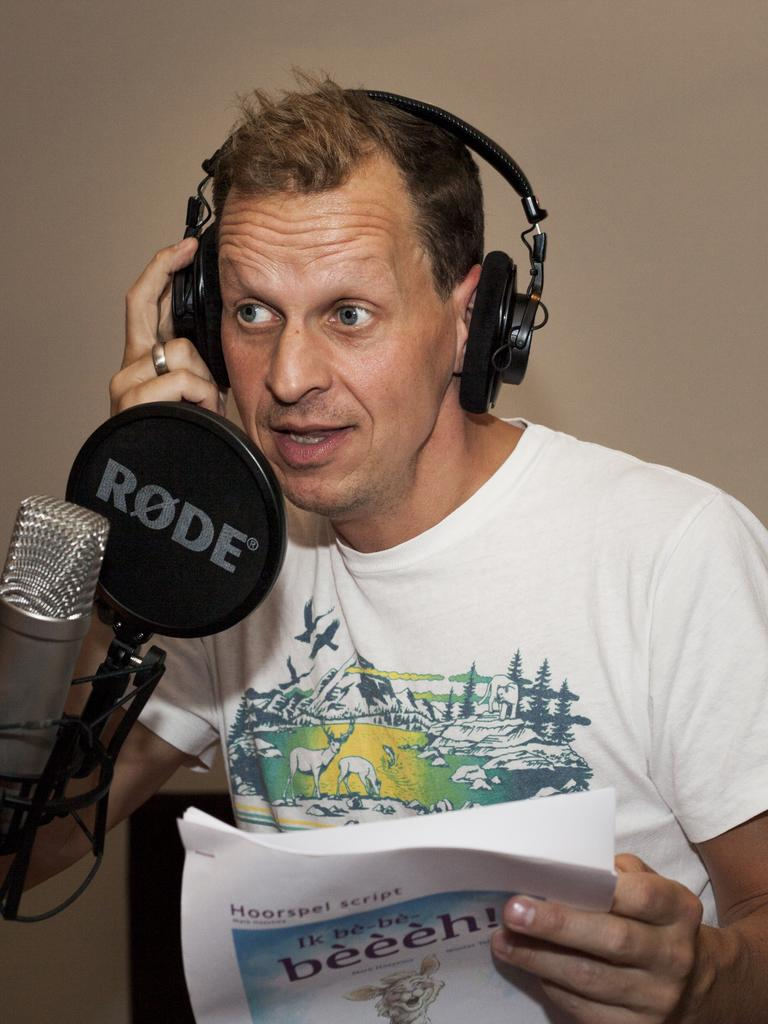What is the man in the image doing? The man is singing in the image. What is the man holding while singing? The man is holding a microphone and papers in his hand. How is the man connected to the sound system? The man is wearing a headset, which is likely connected to the sound system. What can be seen in the background of the image? There is a wall in the background of the image. What type of jam is the man spreading on the wall in the image? There is no jam or any indication of spreading jam in the image. The man is singing and holding a microphone and papers. 